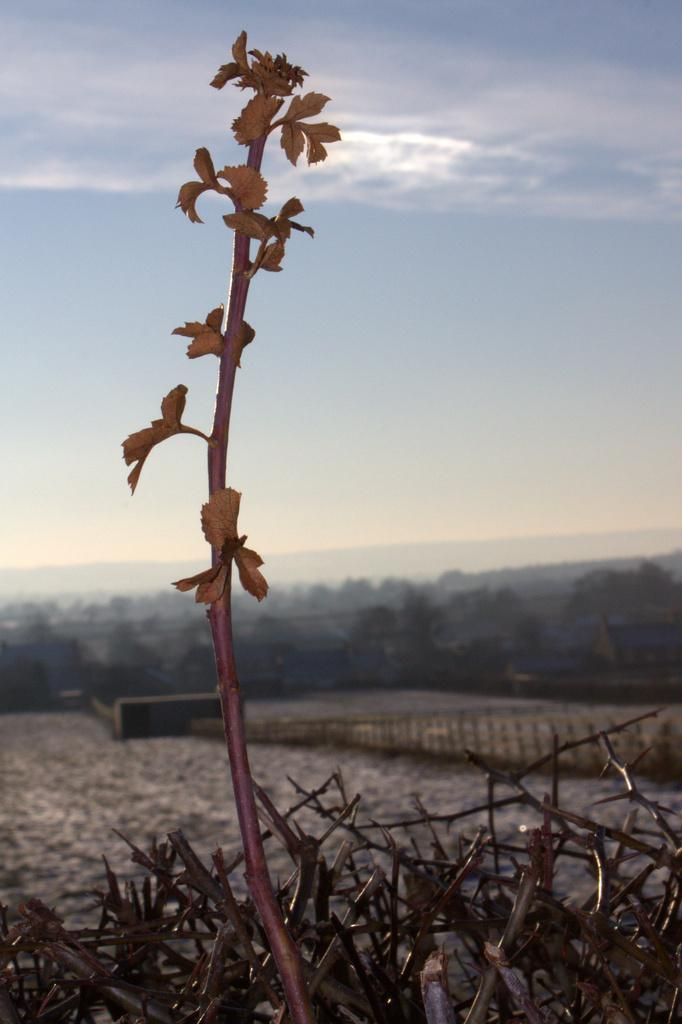What type of vegetation can be seen in the image? There are trees and a plant in the image. Can you describe the sky in the image? The sky is blue and cloudy in the image. What type of poison is being used to expand the trees in the image? There is no mention of poison or expansion in the image; it simply shows trees and a plant with a blue and cloudy sky. 